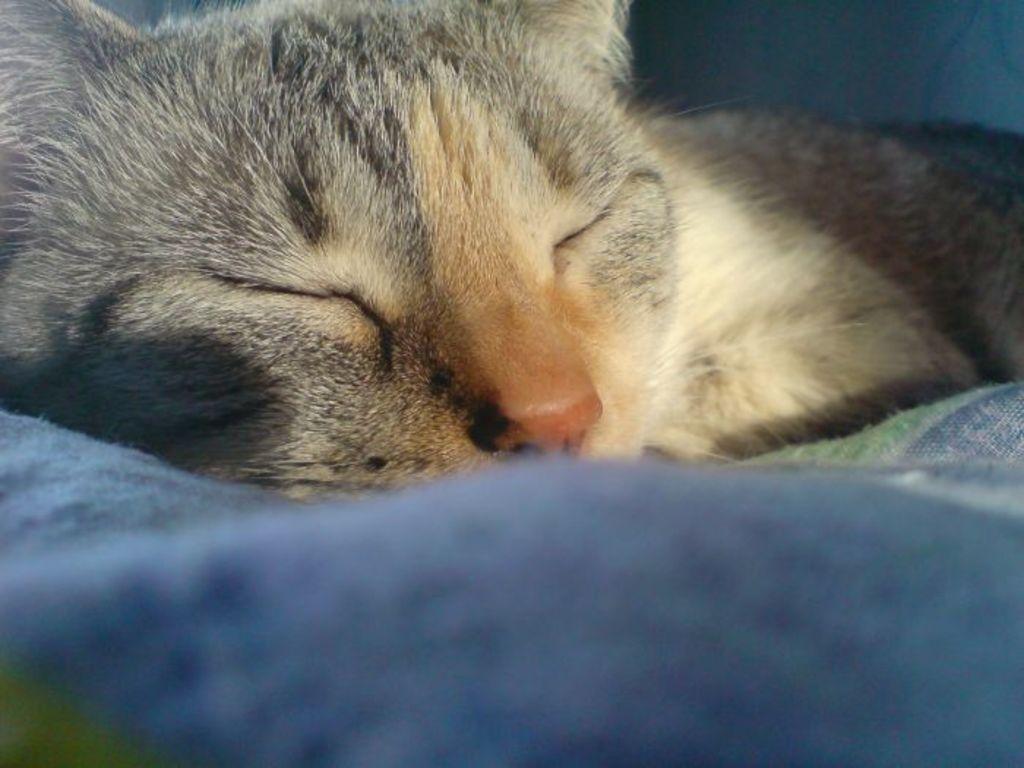Could you give a brief overview of what you see in this image? In this picture we can see a cat is sleeping. At the bottom portion of the picture it seems like a blanket. 